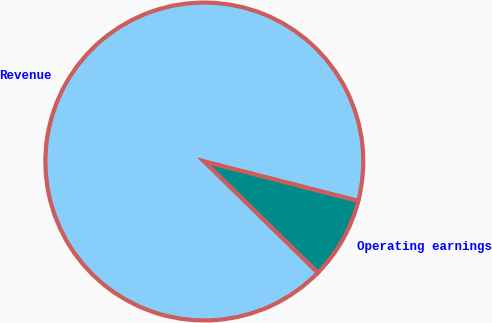Convert chart. <chart><loc_0><loc_0><loc_500><loc_500><pie_chart><fcel>Revenue<fcel>Operating earnings<nl><fcel>91.67%<fcel>8.33%<nl></chart> 